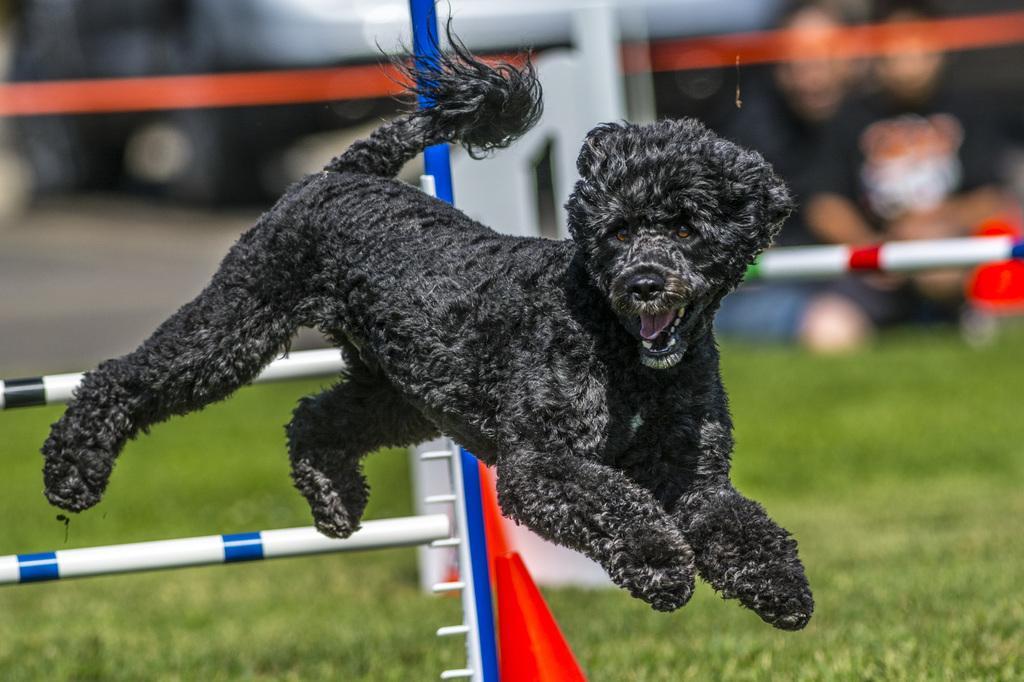In one or two sentences, can you explain what this image depicts? In this image, we can see a dog in the air. In the background, we can see poles, grass, blur view and people. 